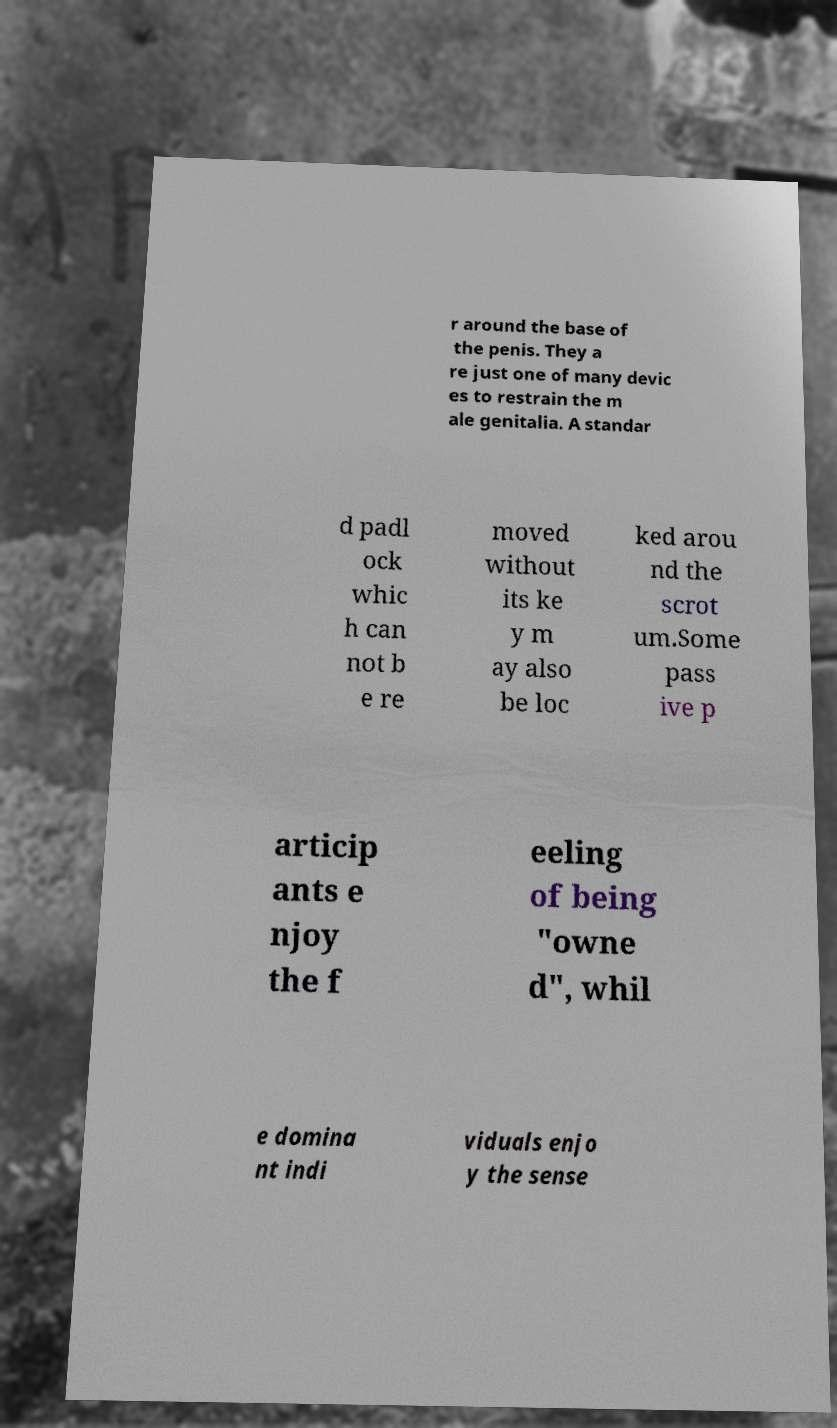Can you read and provide the text displayed in the image?This photo seems to have some interesting text. Can you extract and type it out for me? r around the base of the penis. They a re just one of many devic es to restrain the m ale genitalia. A standar d padl ock whic h can not b e re moved without its ke y m ay also be loc ked arou nd the scrot um.Some pass ive p articip ants e njoy the f eeling of being "owne d", whil e domina nt indi viduals enjo y the sense 